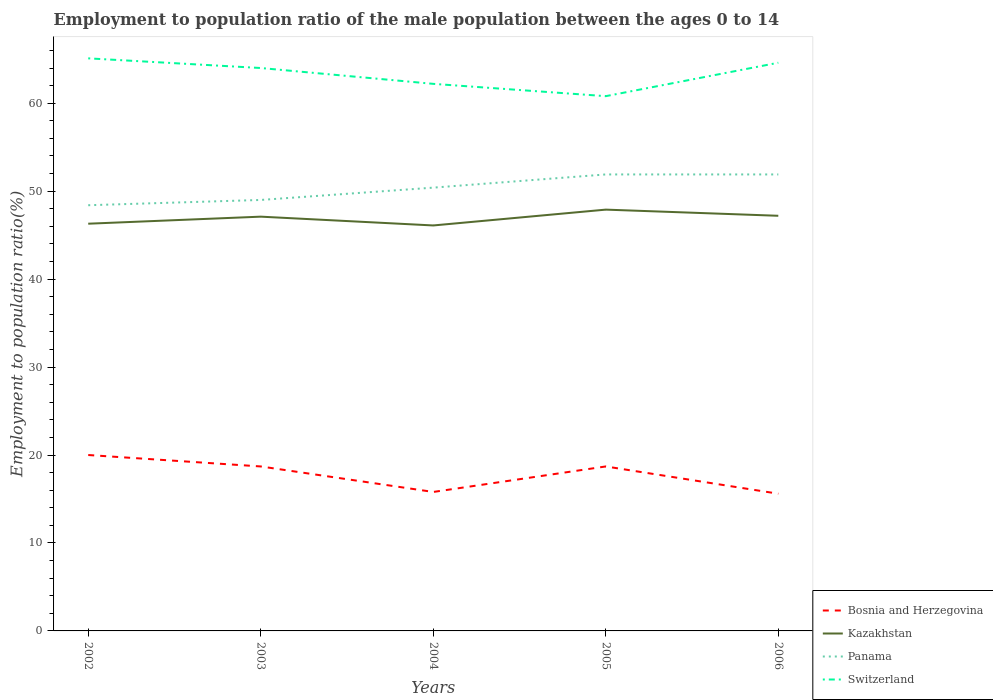How many different coloured lines are there?
Your answer should be very brief. 4. Is the number of lines equal to the number of legend labels?
Offer a very short reply. Yes. Across all years, what is the maximum employment to population ratio in Kazakhstan?
Make the answer very short. 46.1. What is the total employment to population ratio in Switzerland in the graph?
Your response must be concise. 2.9. What is the difference between the highest and the second highest employment to population ratio in Panama?
Offer a very short reply. 3.5. How many years are there in the graph?
Offer a terse response. 5. What is the difference between two consecutive major ticks on the Y-axis?
Give a very brief answer. 10. Does the graph contain any zero values?
Provide a succinct answer. No. Does the graph contain grids?
Your answer should be compact. No. How many legend labels are there?
Offer a terse response. 4. What is the title of the graph?
Provide a succinct answer. Employment to population ratio of the male population between the ages 0 to 14. Does "Sri Lanka" appear as one of the legend labels in the graph?
Provide a short and direct response. No. What is the Employment to population ratio(%) in Bosnia and Herzegovina in 2002?
Keep it short and to the point. 20. What is the Employment to population ratio(%) in Kazakhstan in 2002?
Your answer should be very brief. 46.3. What is the Employment to population ratio(%) in Panama in 2002?
Give a very brief answer. 48.4. What is the Employment to population ratio(%) of Switzerland in 2002?
Your response must be concise. 65.1. What is the Employment to population ratio(%) of Bosnia and Herzegovina in 2003?
Provide a succinct answer. 18.7. What is the Employment to population ratio(%) of Kazakhstan in 2003?
Provide a short and direct response. 47.1. What is the Employment to population ratio(%) of Panama in 2003?
Give a very brief answer. 49. What is the Employment to population ratio(%) in Bosnia and Herzegovina in 2004?
Keep it short and to the point. 15.8. What is the Employment to population ratio(%) of Kazakhstan in 2004?
Offer a terse response. 46.1. What is the Employment to population ratio(%) in Panama in 2004?
Ensure brevity in your answer.  50.4. What is the Employment to population ratio(%) in Switzerland in 2004?
Provide a short and direct response. 62.2. What is the Employment to population ratio(%) of Bosnia and Herzegovina in 2005?
Your answer should be very brief. 18.7. What is the Employment to population ratio(%) of Kazakhstan in 2005?
Your answer should be very brief. 47.9. What is the Employment to population ratio(%) in Panama in 2005?
Offer a very short reply. 51.9. What is the Employment to population ratio(%) in Switzerland in 2005?
Provide a short and direct response. 60.8. What is the Employment to population ratio(%) in Bosnia and Herzegovina in 2006?
Offer a very short reply. 15.6. What is the Employment to population ratio(%) in Kazakhstan in 2006?
Offer a very short reply. 47.2. What is the Employment to population ratio(%) of Panama in 2006?
Make the answer very short. 51.9. What is the Employment to population ratio(%) of Switzerland in 2006?
Your response must be concise. 64.6. Across all years, what is the maximum Employment to population ratio(%) of Kazakhstan?
Provide a succinct answer. 47.9. Across all years, what is the maximum Employment to population ratio(%) in Panama?
Make the answer very short. 51.9. Across all years, what is the maximum Employment to population ratio(%) of Switzerland?
Your response must be concise. 65.1. Across all years, what is the minimum Employment to population ratio(%) of Bosnia and Herzegovina?
Make the answer very short. 15.6. Across all years, what is the minimum Employment to population ratio(%) in Kazakhstan?
Your answer should be compact. 46.1. Across all years, what is the minimum Employment to population ratio(%) in Panama?
Give a very brief answer. 48.4. Across all years, what is the minimum Employment to population ratio(%) of Switzerland?
Your answer should be very brief. 60.8. What is the total Employment to population ratio(%) in Bosnia and Herzegovina in the graph?
Provide a short and direct response. 88.8. What is the total Employment to population ratio(%) in Kazakhstan in the graph?
Ensure brevity in your answer.  234.6. What is the total Employment to population ratio(%) in Panama in the graph?
Make the answer very short. 251.6. What is the total Employment to population ratio(%) of Switzerland in the graph?
Provide a succinct answer. 316.7. What is the difference between the Employment to population ratio(%) of Bosnia and Herzegovina in 2002 and that in 2003?
Ensure brevity in your answer.  1.3. What is the difference between the Employment to population ratio(%) of Kazakhstan in 2002 and that in 2003?
Offer a terse response. -0.8. What is the difference between the Employment to population ratio(%) in Panama in 2002 and that in 2003?
Ensure brevity in your answer.  -0.6. What is the difference between the Employment to population ratio(%) in Switzerland in 2002 and that in 2003?
Offer a very short reply. 1.1. What is the difference between the Employment to population ratio(%) of Kazakhstan in 2002 and that in 2004?
Provide a short and direct response. 0.2. What is the difference between the Employment to population ratio(%) in Panama in 2002 and that in 2005?
Keep it short and to the point. -3.5. What is the difference between the Employment to population ratio(%) of Switzerland in 2002 and that in 2005?
Your response must be concise. 4.3. What is the difference between the Employment to population ratio(%) of Bosnia and Herzegovina in 2002 and that in 2006?
Your answer should be very brief. 4.4. What is the difference between the Employment to population ratio(%) of Switzerland in 2002 and that in 2006?
Your response must be concise. 0.5. What is the difference between the Employment to population ratio(%) in Bosnia and Herzegovina in 2003 and that in 2004?
Keep it short and to the point. 2.9. What is the difference between the Employment to population ratio(%) in Panama in 2003 and that in 2004?
Your response must be concise. -1.4. What is the difference between the Employment to population ratio(%) of Switzerland in 2003 and that in 2004?
Ensure brevity in your answer.  1.8. What is the difference between the Employment to population ratio(%) in Panama in 2003 and that in 2005?
Provide a succinct answer. -2.9. What is the difference between the Employment to population ratio(%) of Bosnia and Herzegovina in 2003 and that in 2006?
Offer a very short reply. 3.1. What is the difference between the Employment to population ratio(%) of Kazakhstan in 2003 and that in 2006?
Provide a succinct answer. -0.1. What is the difference between the Employment to population ratio(%) of Panama in 2003 and that in 2006?
Give a very brief answer. -2.9. What is the difference between the Employment to population ratio(%) of Kazakhstan in 2004 and that in 2005?
Offer a very short reply. -1.8. What is the difference between the Employment to population ratio(%) of Panama in 2004 and that in 2006?
Your answer should be compact. -1.5. What is the difference between the Employment to population ratio(%) of Bosnia and Herzegovina in 2005 and that in 2006?
Offer a very short reply. 3.1. What is the difference between the Employment to population ratio(%) in Panama in 2005 and that in 2006?
Offer a terse response. 0. What is the difference between the Employment to population ratio(%) of Bosnia and Herzegovina in 2002 and the Employment to population ratio(%) of Kazakhstan in 2003?
Your response must be concise. -27.1. What is the difference between the Employment to population ratio(%) of Bosnia and Herzegovina in 2002 and the Employment to population ratio(%) of Panama in 2003?
Give a very brief answer. -29. What is the difference between the Employment to population ratio(%) of Bosnia and Herzegovina in 2002 and the Employment to population ratio(%) of Switzerland in 2003?
Keep it short and to the point. -44. What is the difference between the Employment to population ratio(%) in Kazakhstan in 2002 and the Employment to population ratio(%) in Switzerland in 2003?
Keep it short and to the point. -17.7. What is the difference between the Employment to population ratio(%) in Panama in 2002 and the Employment to population ratio(%) in Switzerland in 2003?
Provide a short and direct response. -15.6. What is the difference between the Employment to population ratio(%) of Bosnia and Herzegovina in 2002 and the Employment to population ratio(%) of Kazakhstan in 2004?
Provide a short and direct response. -26.1. What is the difference between the Employment to population ratio(%) of Bosnia and Herzegovina in 2002 and the Employment to population ratio(%) of Panama in 2004?
Provide a short and direct response. -30.4. What is the difference between the Employment to population ratio(%) of Bosnia and Herzegovina in 2002 and the Employment to population ratio(%) of Switzerland in 2004?
Your answer should be very brief. -42.2. What is the difference between the Employment to population ratio(%) of Kazakhstan in 2002 and the Employment to population ratio(%) of Panama in 2004?
Your response must be concise. -4.1. What is the difference between the Employment to population ratio(%) in Kazakhstan in 2002 and the Employment to population ratio(%) in Switzerland in 2004?
Provide a succinct answer. -15.9. What is the difference between the Employment to population ratio(%) of Bosnia and Herzegovina in 2002 and the Employment to population ratio(%) of Kazakhstan in 2005?
Your answer should be very brief. -27.9. What is the difference between the Employment to population ratio(%) in Bosnia and Herzegovina in 2002 and the Employment to population ratio(%) in Panama in 2005?
Provide a short and direct response. -31.9. What is the difference between the Employment to population ratio(%) of Bosnia and Herzegovina in 2002 and the Employment to population ratio(%) of Switzerland in 2005?
Your response must be concise. -40.8. What is the difference between the Employment to population ratio(%) in Kazakhstan in 2002 and the Employment to population ratio(%) in Panama in 2005?
Keep it short and to the point. -5.6. What is the difference between the Employment to population ratio(%) in Kazakhstan in 2002 and the Employment to population ratio(%) in Switzerland in 2005?
Offer a terse response. -14.5. What is the difference between the Employment to population ratio(%) in Bosnia and Herzegovina in 2002 and the Employment to population ratio(%) in Kazakhstan in 2006?
Provide a succinct answer. -27.2. What is the difference between the Employment to population ratio(%) in Bosnia and Herzegovina in 2002 and the Employment to population ratio(%) in Panama in 2006?
Your answer should be very brief. -31.9. What is the difference between the Employment to population ratio(%) in Bosnia and Herzegovina in 2002 and the Employment to population ratio(%) in Switzerland in 2006?
Your answer should be very brief. -44.6. What is the difference between the Employment to population ratio(%) of Kazakhstan in 2002 and the Employment to population ratio(%) of Switzerland in 2006?
Keep it short and to the point. -18.3. What is the difference between the Employment to population ratio(%) of Panama in 2002 and the Employment to population ratio(%) of Switzerland in 2006?
Your answer should be compact. -16.2. What is the difference between the Employment to population ratio(%) in Bosnia and Herzegovina in 2003 and the Employment to population ratio(%) in Kazakhstan in 2004?
Offer a very short reply. -27.4. What is the difference between the Employment to population ratio(%) of Bosnia and Herzegovina in 2003 and the Employment to population ratio(%) of Panama in 2004?
Your response must be concise. -31.7. What is the difference between the Employment to population ratio(%) in Bosnia and Herzegovina in 2003 and the Employment to population ratio(%) in Switzerland in 2004?
Your answer should be very brief. -43.5. What is the difference between the Employment to population ratio(%) of Kazakhstan in 2003 and the Employment to population ratio(%) of Panama in 2004?
Your response must be concise. -3.3. What is the difference between the Employment to population ratio(%) of Kazakhstan in 2003 and the Employment to population ratio(%) of Switzerland in 2004?
Offer a very short reply. -15.1. What is the difference between the Employment to population ratio(%) of Bosnia and Herzegovina in 2003 and the Employment to population ratio(%) of Kazakhstan in 2005?
Ensure brevity in your answer.  -29.2. What is the difference between the Employment to population ratio(%) of Bosnia and Herzegovina in 2003 and the Employment to population ratio(%) of Panama in 2005?
Offer a very short reply. -33.2. What is the difference between the Employment to population ratio(%) in Bosnia and Herzegovina in 2003 and the Employment to population ratio(%) in Switzerland in 2005?
Provide a short and direct response. -42.1. What is the difference between the Employment to population ratio(%) of Kazakhstan in 2003 and the Employment to population ratio(%) of Panama in 2005?
Provide a succinct answer. -4.8. What is the difference between the Employment to population ratio(%) of Kazakhstan in 2003 and the Employment to population ratio(%) of Switzerland in 2005?
Provide a succinct answer. -13.7. What is the difference between the Employment to population ratio(%) of Panama in 2003 and the Employment to population ratio(%) of Switzerland in 2005?
Ensure brevity in your answer.  -11.8. What is the difference between the Employment to population ratio(%) of Bosnia and Herzegovina in 2003 and the Employment to population ratio(%) of Kazakhstan in 2006?
Ensure brevity in your answer.  -28.5. What is the difference between the Employment to population ratio(%) in Bosnia and Herzegovina in 2003 and the Employment to population ratio(%) in Panama in 2006?
Make the answer very short. -33.2. What is the difference between the Employment to population ratio(%) of Bosnia and Herzegovina in 2003 and the Employment to population ratio(%) of Switzerland in 2006?
Offer a very short reply. -45.9. What is the difference between the Employment to population ratio(%) in Kazakhstan in 2003 and the Employment to population ratio(%) in Panama in 2006?
Your answer should be compact. -4.8. What is the difference between the Employment to population ratio(%) of Kazakhstan in 2003 and the Employment to population ratio(%) of Switzerland in 2006?
Your answer should be very brief. -17.5. What is the difference between the Employment to population ratio(%) in Panama in 2003 and the Employment to population ratio(%) in Switzerland in 2006?
Offer a terse response. -15.6. What is the difference between the Employment to population ratio(%) in Bosnia and Herzegovina in 2004 and the Employment to population ratio(%) in Kazakhstan in 2005?
Your answer should be compact. -32.1. What is the difference between the Employment to population ratio(%) in Bosnia and Herzegovina in 2004 and the Employment to population ratio(%) in Panama in 2005?
Ensure brevity in your answer.  -36.1. What is the difference between the Employment to population ratio(%) of Bosnia and Herzegovina in 2004 and the Employment to population ratio(%) of Switzerland in 2005?
Give a very brief answer. -45. What is the difference between the Employment to population ratio(%) in Kazakhstan in 2004 and the Employment to population ratio(%) in Panama in 2005?
Make the answer very short. -5.8. What is the difference between the Employment to population ratio(%) in Kazakhstan in 2004 and the Employment to population ratio(%) in Switzerland in 2005?
Ensure brevity in your answer.  -14.7. What is the difference between the Employment to population ratio(%) in Panama in 2004 and the Employment to population ratio(%) in Switzerland in 2005?
Provide a succinct answer. -10.4. What is the difference between the Employment to population ratio(%) of Bosnia and Herzegovina in 2004 and the Employment to population ratio(%) of Kazakhstan in 2006?
Provide a short and direct response. -31.4. What is the difference between the Employment to population ratio(%) of Bosnia and Herzegovina in 2004 and the Employment to population ratio(%) of Panama in 2006?
Give a very brief answer. -36.1. What is the difference between the Employment to population ratio(%) in Bosnia and Herzegovina in 2004 and the Employment to population ratio(%) in Switzerland in 2006?
Provide a short and direct response. -48.8. What is the difference between the Employment to population ratio(%) of Kazakhstan in 2004 and the Employment to population ratio(%) of Switzerland in 2006?
Your response must be concise. -18.5. What is the difference between the Employment to population ratio(%) of Bosnia and Herzegovina in 2005 and the Employment to population ratio(%) of Kazakhstan in 2006?
Ensure brevity in your answer.  -28.5. What is the difference between the Employment to population ratio(%) in Bosnia and Herzegovina in 2005 and the Employment to population ratio(%) in Panama in 2006?
Offer a very short reply. -33.2. What is the difference between the Employment to population ratio(%) in Bosnia and Herzegovina in 2005 and the Employment to population ratio(%) in Switzerland in 2006?
Provide a short and direct response. -45.9. What is the difference between the Employment to population ratio(%) in Kazakhstan in 2005 and the Employment to population ratio(%) in Switzerland in 2006?
Provide a succinct answer. -16.7. What is the difference between the Employment to population ratio(%) of Panama in 2005 and the Employment to population ratio(%) of Switzerland in 2006?
Your answer should be compact. -12.7. What is the average Employment to population ratio(%) in Bosnia and Herzegovina per year?
Keep it short and to the point. 17.76. What is the average Employment to population ratio(%) in Kazakhstan per year?
Offer a very short reply. 46.92. What is the average Employment to population ratio(%) in Panama per year?
Provide a short and direct response. 50.32. What is the average Employment to population ratio(%) of Switzerland per year?
Provide a short and direct response. 63.34. In the year 2002, what is the difference between the Employment to population ratio(%) in Bosnia and Herzegovina and Employment to population ratio(%) in Kazakhstan?
Offer a very short reply. -26.3. In the year 2002, what is the difference between the Employment to population ratio(%) in Bosnia and Herzegovina and Employment to population ratio(%) in Panama?
Provide a short and direct response. -28.4. In the year 2002, what is the difference between the Employment to population ratio(%) in Bosnia and Herzegovina and Employment to population ratio(%) in Switzerland?
Provide a short and direct response. -45.1. In the year 2002, what is the difference between the Employment to population ratio(%) in Kazakhstan and Employment to population ratio(%) in Switzerland?
Keep it short and to the point. -18.8. In the year 2002, what is the difference between the Employment to population ratio(%) in Panama and Employment to population ratio(%) in Switzerland?
Keep it short and to the point. -16.7. In the year 2003, what is the difference between the Employment to population ratio(%) in Bosnia and Herzegovina and Employment to population ratio(%) in Kazakhstan?
Provide a short and direct response. -28.4. In the year 2003, what is the difference between the Employment to population ratio(%) of Bosnia and Herzegovina and Employment to population ratio(%) of Panama?
Offer a terse response. -30.3. In the year 2003, what is the difference between the Employment to population ratio(%) in Bosnia and Herzegovina and Employment to population ratio(%) in Switzerland?
Your answer should be very brief. -45.3. In the year 2003, what is the difference between the Employment to population ratio(%) in Kazakhstan and Employment to population ratio(%) in Switzerland?
Offer a very short reply. -16.9. In the year 2003, what is the difference between the Employment to population ratio(%) in Panama and Employment to population ratio(%) in Switzerland?
Offer a very short reply. -15. In the year 2004, what is the difference between the Employment to population ratio(%) of Bosnia and Herzegovina and Employment to population ratio(%) of Kazakhstan?
Your response must be concise. -30.3. In the year 2004, what is the difference between the Employment to population ratio(%) in Bosnia and Herzegovina and Employment to population ratio(%) in Panama?
Your answer should be very brief. -34.6. In the year 2004, what is the difference between the Employment to population ratio(%) of Bosnia and Herzegovina and Employment to population ratio(%) of Switzerland?
Your response must be concise. -46.4. In the year 2004, what is the difference between the Employment to population ratio(%) in Kazakhstan and Employment to population ratio(%) in Switzerland?
Keep it short and to the point. -16.1. In the year 2005, what is the difference between the Employment to population ratio(%) of Bosnia and Herzegovina and Employment to population ratio(%) of Kazakhstan?
Your response must be concise. -29.2. In the year 2005, what is the difference between the Employment to population ratio(%) of Bosnia and Herzegovina and Employment to population ratio(%) of Panama?
Your answer should be very brief. -33.2. In the year 2005, what is the difference between the Employment to population ratio(%) in Bosnia and Herzegovina and Employment to population ratio(%) in Switzerland?
Keep it short and to the point. -42.1. In the year 2005, what is the difference between the Employment to population ratio(%) of Kazakhstan and Employment to population ratio(%) of Panama?
Your answer should be very brief. -4. In the year 2005, what is the difference between the Employment to population ratio(%) of Kazakhstan and Employment to population ratio(%) of Switzerland?
Ensure brevity in your answer.  -12.9. In the year 2006, what is the difference between the Employment to population ratio(%) of Bosnia and Herzegovina and Employment to population ratio(%) of Kazakhstan?
Ensure brevity in your answer.  -31.6. In the year 2006, what is the difference between the Employment to population ratio(%) of Bosnia and Herzegovina and Employment to population ratio(%) of Panama?
Keep it short and to the point. -36.3. In the year 2006, what is the difference between the Employment to population ratio(%) of Bosnia and Herzegovina and Employment to population ratio(%) of Switzerland?
Make the answer very short. -49. In the year 2006, what is the difference between the Employment to population ratio(%) of Kazakhstan and Employment to population ratio(%) of Panama?
Your answer should be compact. -4.7. In the year 2006, what is the difference between the Employment to population ratio(%) in Kazakhstan and Employment to population ratio(%) in Switzerland?
Make the answer very short. -17.4. In the year 2006, what is the difference between the Employment to population ratio(%) in Panama and Employment to population ratio(%) in Switzerland?
Your answer should be very brief. -12.7. What is the ratio of the Employment to population ratio(%) in Bosnia and Herzegovina in 2002 to that in 2003?
Offer a very short reply. 1.07. What is the ratio of the Employment to population ratio(%) of Kazakhstan in 2002 to that in 2003?
Your answer should be very brief. 0.98. What is the ratio of the Employment to population ratio(%) in Panama in 2002 to that in 2003?
Your answer should be very brief. 0.99. What is the ratio of the Employment to population ratio(%) in Switzerland in 2002 to that in 2003?
Provide a succinct answer. 1.02. What is the ratio of the Employment to population ratio(%) in Bosnia and Herzegovina in 2002 to that in 2004?
Your answer should be compact. 1.27. What is the ratio of the Employment to population ratio(%) in Panama in 2002 to that in 2004?
Provide a short and direct response. 0.96. What is the ratio of the Employment to population ratio(%) of Switzerland in 2002 to that in 2004?
Offer a terse response. 1.05. What is the ratio of the Employment to population ratio(%) in Bosnia and Herzegovina in 2002 to that in 2005?
Provide a short and direct response. 1.07. What is the ratio of the Employment to population ratio(%) in Kazakhstan in 2002 to that in 2005?
Keep it short and to the point. 0.97. What is the ratio of the Employment to population ratio(%) of Panama in 2002 to that in 2005?
Keep it short and to the point. 0.93. What is the ratio of the Employment to population ratio(%) of Switzerland in 2002 to that in 2005?
Give a very brief answer. 1.07. What is the ratio of the Employment to population ratio(%) in Bosnia and Herzegovina in 2002 to that in 2006?
Make the answer very short. 1.28. What is the ratio of the Employment to population ratio(%) of Kazakhstan in 2002 to that in 2006?
Offer a very short reply. 0.98. What is the ratio of the Employment to population ratio(%) of Panama in 2002 to that in 2006?
Keep it short and to the point. 0.93. What is the ratio of the Employment to population ratio(%) of Switzerland in 2002 to that in 2006?
Ensure brevity in your answer.  1.01. What is the ratio of the Employment to population ratio(%) of Bosnia and Herzegovina in 2003 to that in 2004?
Provide a succinct answer. 1.18. What is the ratio of the Employment to population ratio(%) of Kazakhstan in 2003 to that in 2004?
Keep it short and to the point. 1.02. What is the ratio of the Employment to population ratio(%) of Panama in 2003 to that in 2004?
Make the answer very short. 0.97. What is the ratio of the Employment to population ratio(%) in Switzerland in 2003 to that in 2004?
Keep it short and to the point. 1.03. What is the ratio of the Employment to population ratio(%) in Kazakhstan in 2003 to that in 2005?
Provide a succinct answer. 0.98. What is the ratio of the Employment to population ratio(%) of Panama in 2003 to that in 2005?
Make the answer very short. 0.94. What is the ratio of the Employment to population ratio(%) in Switzerland in 2003 to that in 2005?
Provide a succinct answer. 1.05. What is the ratio of the Employment to population ratio(%) of Bosnia and Herzegovina in 2003 to that in 2006?
Offer a very short reply. 1.2. What is the ratio of the Employment to population ratio(%) in Panama in 2003 to that in 2006?
Offer a terse response. 0.94. What is the ratio of the Employment to population ratio(%) in Bosnia and Herzegovina in 2004 to that in 2005?
Ensure brevity in your answer.  0.84. What is the ratio of the Employment to population ratio(%) in Kazakhstan in 2004 to that in 2005?
Ensure brevity in your answer.  0.96. What is the ratio of the Employment to population ratio(%) of Panama in 2004 to that in 2005?
Ensure brevity in your answer.  0.97. What is the ratio of the Employment to population ratio(%) of Bosnia and Herzegovina in 2004 to that in 2006?
Give a very brief answer. 1.01. What is the ratio of the Employment to population ratio(%) in Kazakhstan in 2004 to that in 2006?
Your response must be concise. 0.98. What is the ratio of the Employment to population ratio(%) of Panama in 2004 to that in 2006?
Offer a very short reply. 0.97. What is the ratio of the Employment to population ratio(%) in Switzerland in 2004 to that in 2006?
Offer a terse response. 0.96. What is the ratio of the Employment to population ratio(%) in Bosnia and Herzegovina in 2005 to that in 2006?
Your answer should be very brief. 1.2. What is the ratio of the Employment to population ratio(%) of Kazakhstan in 2005 to that in 2006?
Your response must be concise. 1.01. What is the ratio of the Employment to population ratio(%) in Panama in 2005 to that in 2006?
Offer a very short reply. 1. What is the ratio of the Employment to population ratio(%) of Switzerland in 2005 to that in 2006?
Ensure brevity in your answer.  0.94. What is the difference between the highest and the second highest Employment to population ratio(%) in Kazakhstan?
Offer a terse response. 0.7. What is the difference between the highest and the lowest Employment to population ratio(%) in Kazakhstan?
Your answer should be compact. 1.8. 